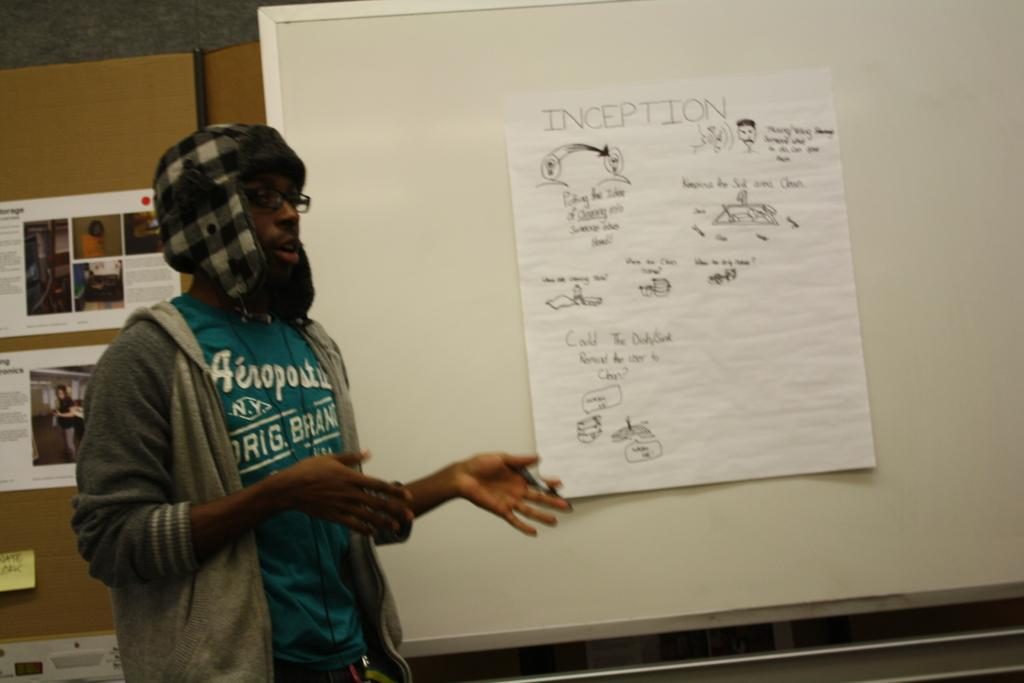<image>
Provide a brief description of the given image. the word inception is on a piece of paper 